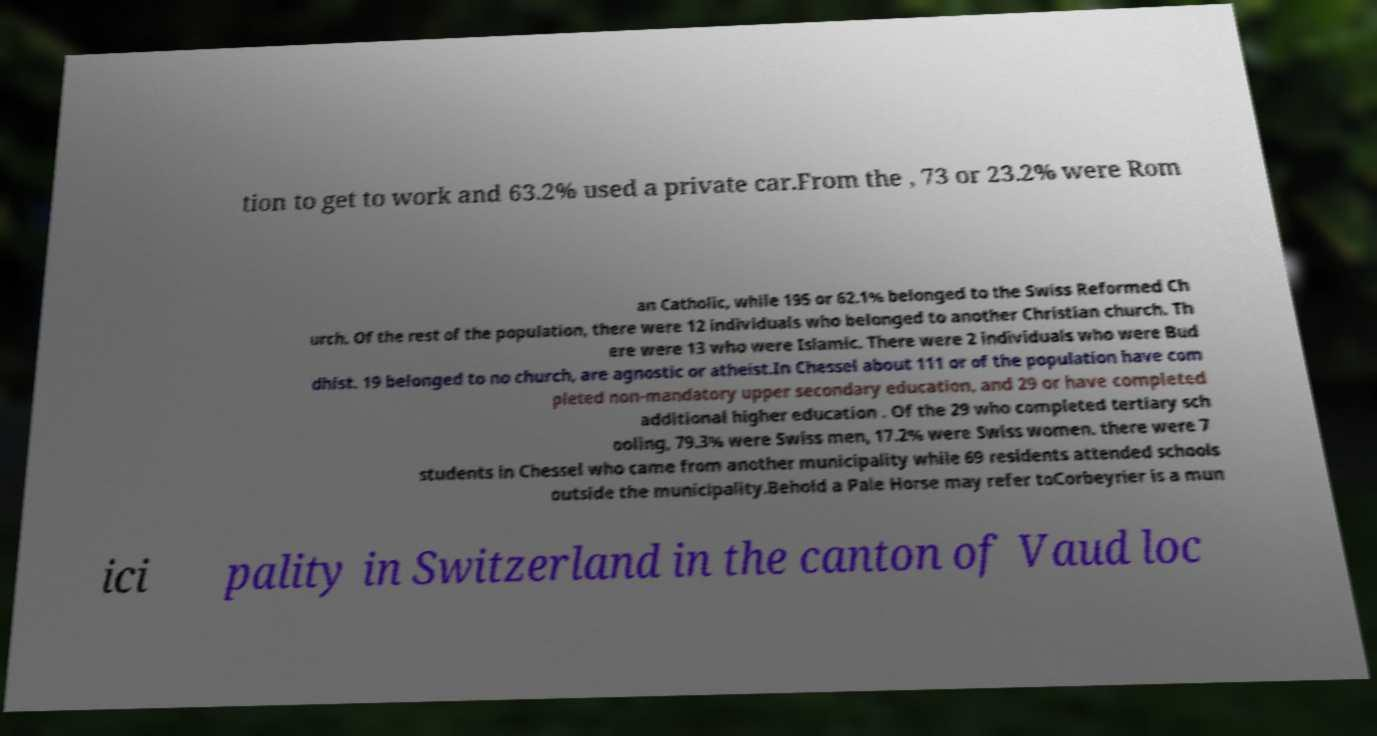Please identify and transcribe the text found in this image. tion to get to work and 63.2% used a private car.From the , 73 or 23.2% were Rom an Catholic, while 195 or 62.1% belonged to the Swiss Reformed Ch urch. Of the rest of the population, there were 12 individuals who belonged to another Christian church. Th ere were 13 who were Islamic. There were 2 individuals who were Bud dhist. 19 belonged to no church, are agnostic or atheist.In Chessel about 111 or of the population have com pleted non-mandatory upper secondary education, and 29 or have completed additional higher education . Of the 29 who completed tertiary sch ooling, 79.3% were Swiss men, 17.2% were Swiss women. there were 7 students in Chessel who came from another municipality while 69 residents attended schools outside the municipality.Behold a Pale Horse may refer toCorbeyrier is a mun ici pality in Switzerland in the canton of Vaud loc 